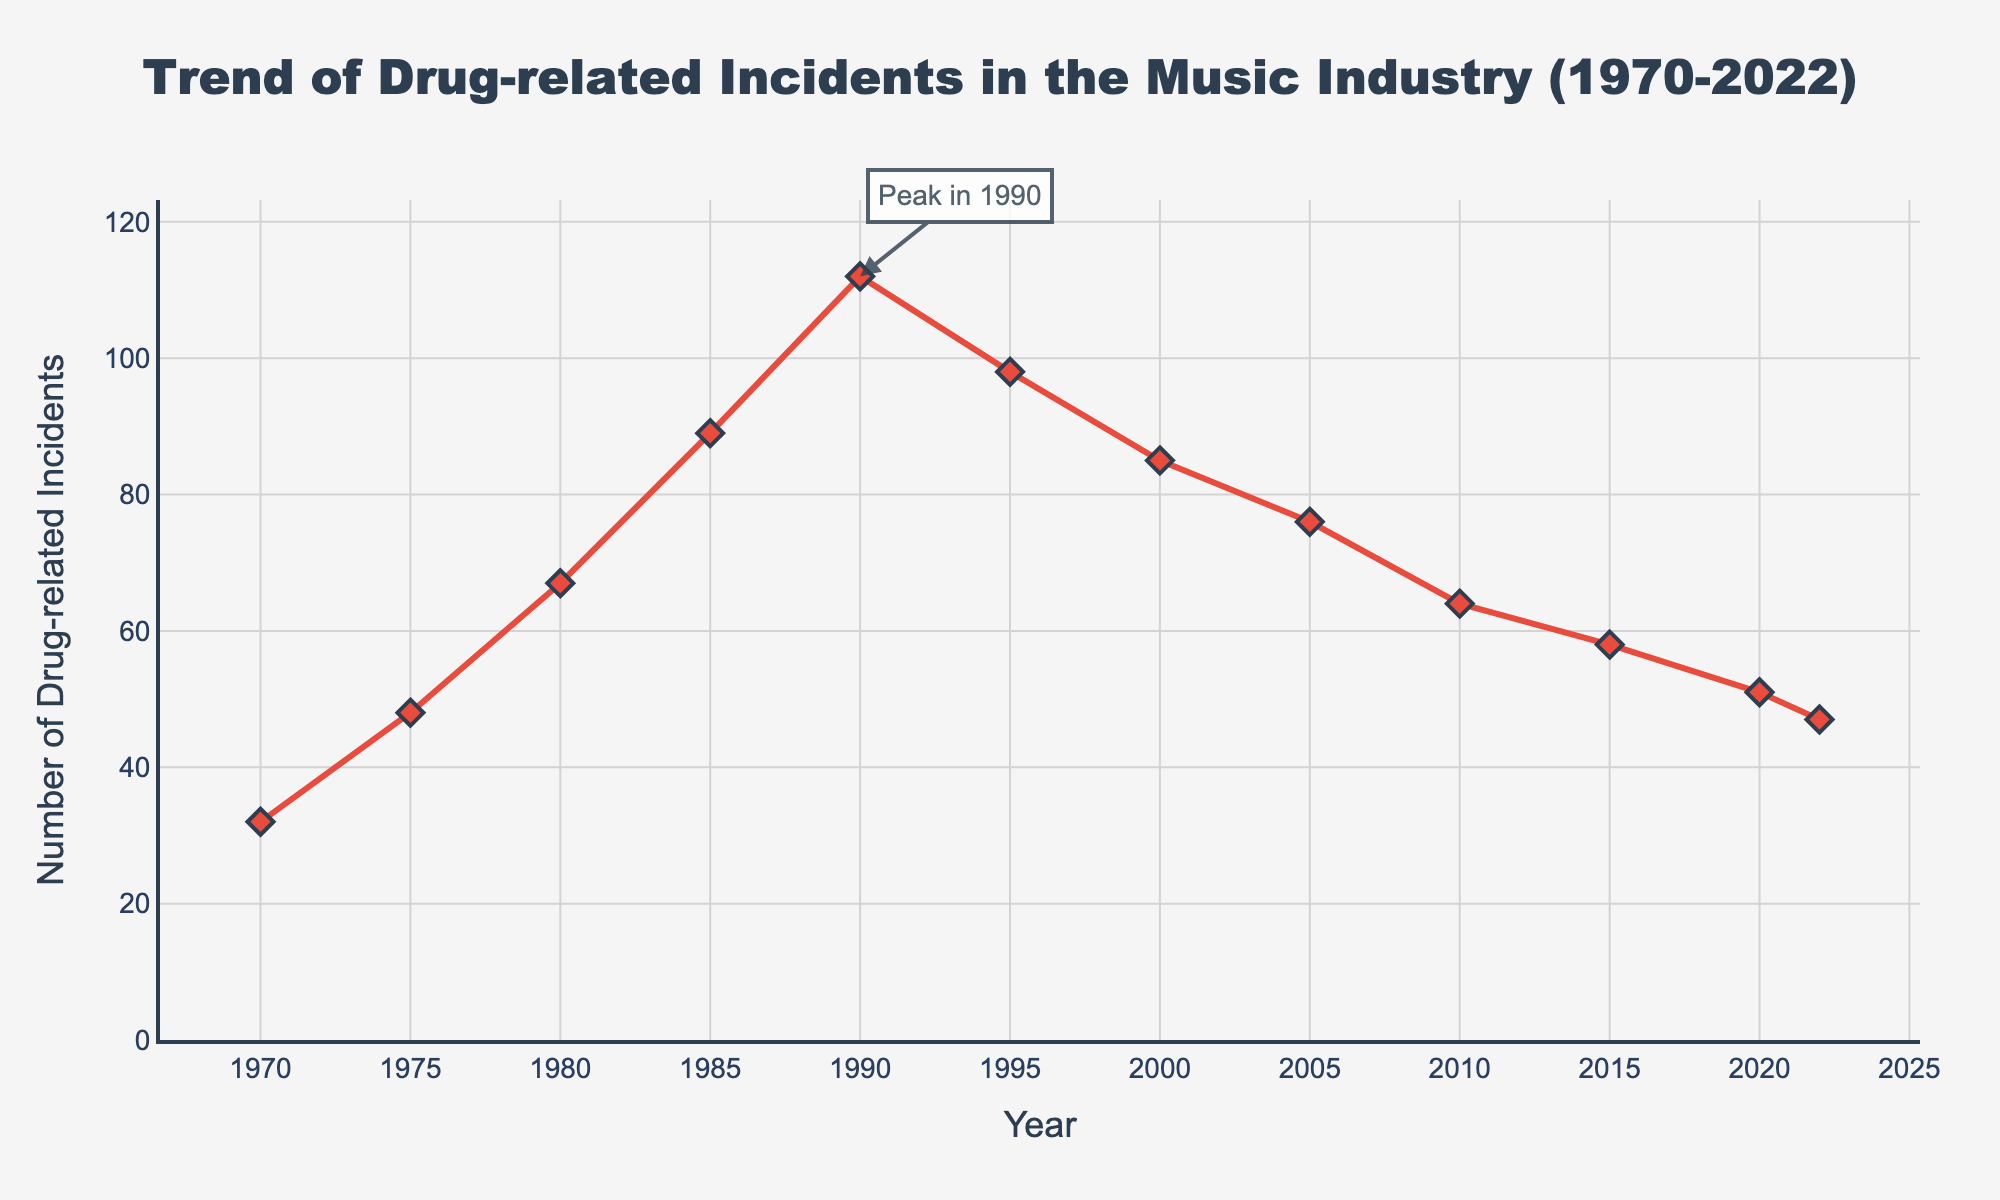What's the highest number of drug-related incidents observed in the chart? The visual on the chart peaks at 112 drug-related incidents. This point is marked by an annotation, making it easy to spot.
Answer: 112 During which year did drug-related incidents peak? According to the annotation and the visual spike in the chart, drug-related incidents peaked in the year 1990.
Answer: 1990 What is the total number of drug-related incidents from 1970 to 1980? Sum the drug-related incidents for the years 1970, 1975, and 1980: 32 + 48 + 67 = 147
Answer: 147 In which years did the drug-related incidents decrease compared to the previous year? Review the chart and note the years where incidents are lower than the previous marked year: 1995 to 2000, 2000 to 2005, 2005 to 2010, 2010 to 2015, 2015 to 2020, and 2020 to 2022.
Answer: 1995 to 2000, 2000 to 2005, 2005 to 2010, 2010 to 2015, 2015 to 2020, 2020 to 2022 How much did the number of drug-related incidents decrease from 1990 to 2022? Subtract the number of incidents in 2022 from those in 1990: 112 - 47 = 65
Answer: 65 How does the trend of drug-related incidents before 1990 compare to the trend after 1990? Before 1990, the number of incidents is increasing, while after 1990, despite some fluctuations, there is an overall declining trend.
Answer: Increasing before 1990, decreasing after 1990 What are the average drug-related incidents for the decades 1970s, 1980s, and 1990s? Calculate the mean for each decade:
1970s: (32 + 48 + 67) / 3 = 49
1980s: (67 + 89 + 112) / 3 = 89.33
1990s: (112 + 98 + 85) / 3 = 98.33
Answer: 49, 89.33, 98.33 Which year had fewer than 50 drug-related incidents but not the lowest? Review the chart for years with fewer than 50 incidents, but not the lowest value (32 in 1970). The year 2022 fits this criterion with 47 incidents.
Answer: 2022 What is the percentage decrease in drug-related incidents from the peak year to the most recent year? Calculate the percentage decrease: ((112 - 47) / 112) * 100 = 58.04%
Answer: 58.04% What visual elements indicate the peak year and the overall trend of incidents? The annotation clearly marks 1990 as the peak year. The overall trend is visualized by the line, which rises until 1990 and generally declines thereafter.
Answer: Annotation and line trend 